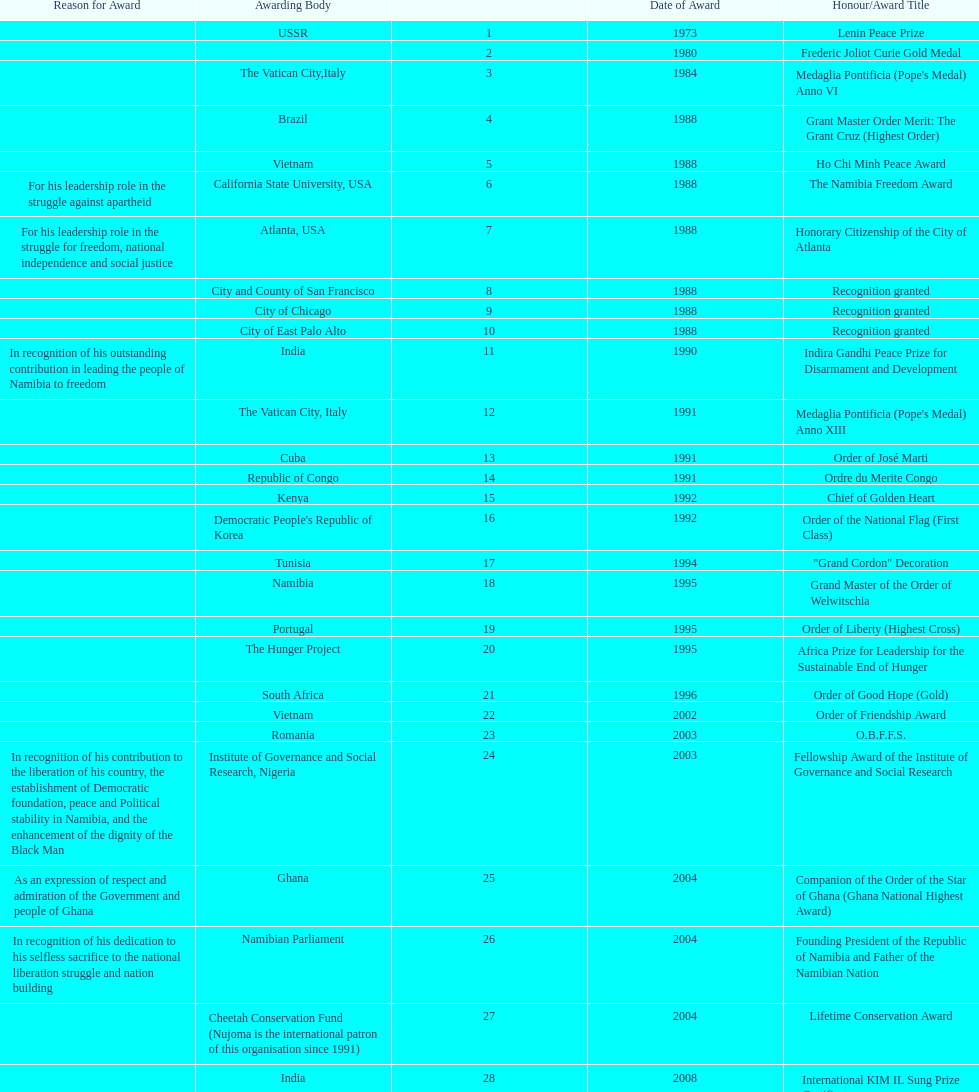What was the last award that nujoma won? Sir Seretse Khama SADC Meda. 